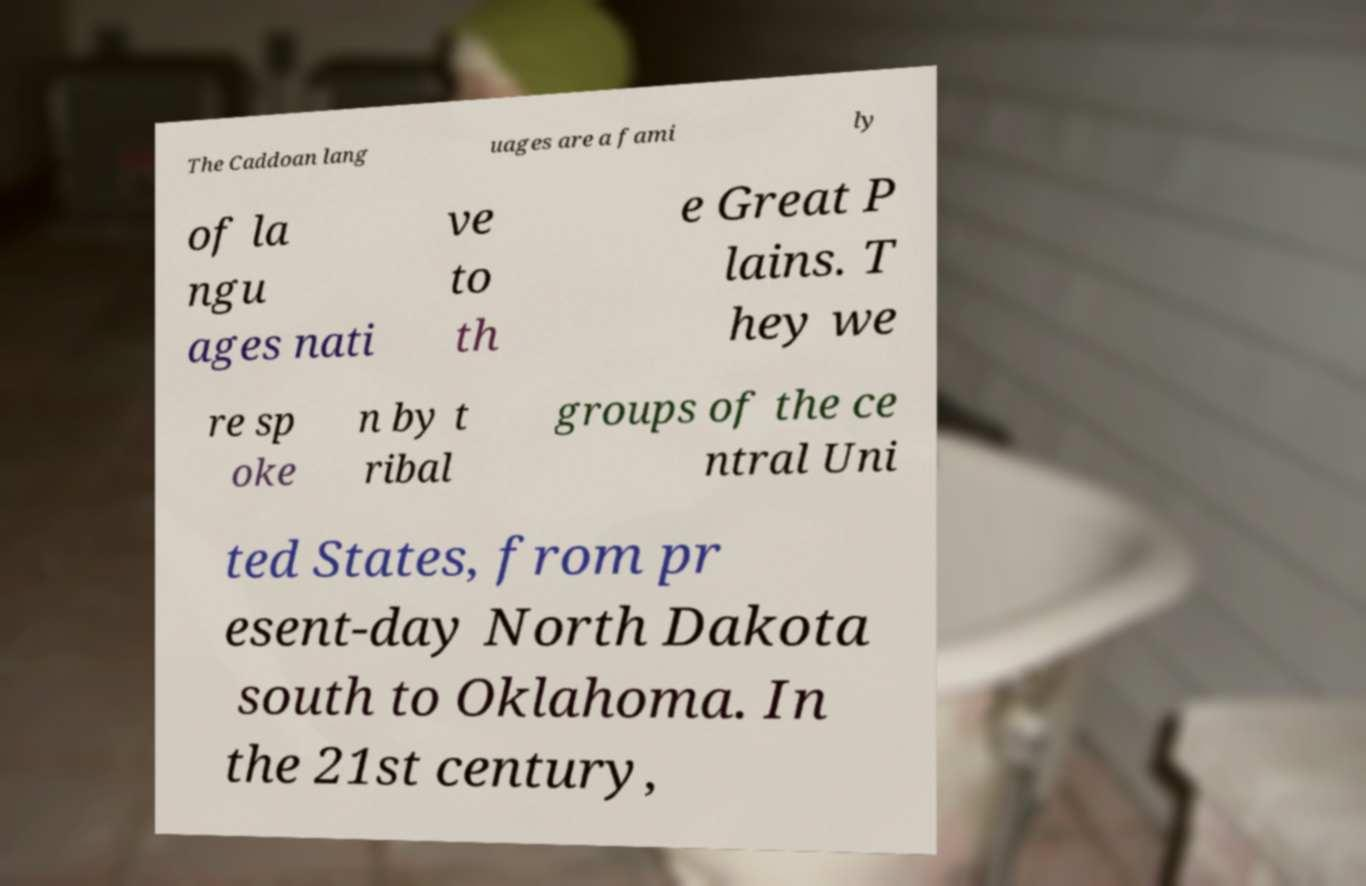There's text embedded in this image that I need extracted. Can you transcribe it verbatim? The Caddoan lang uages are a fami ly of la ngu ages nati ve to th e Great P lains. T hey we re sp oke n by t ribal groups of the ce ntral Uni ted States, from pr esent-day North Dakota south to Oklahoma. In the 21st century, 